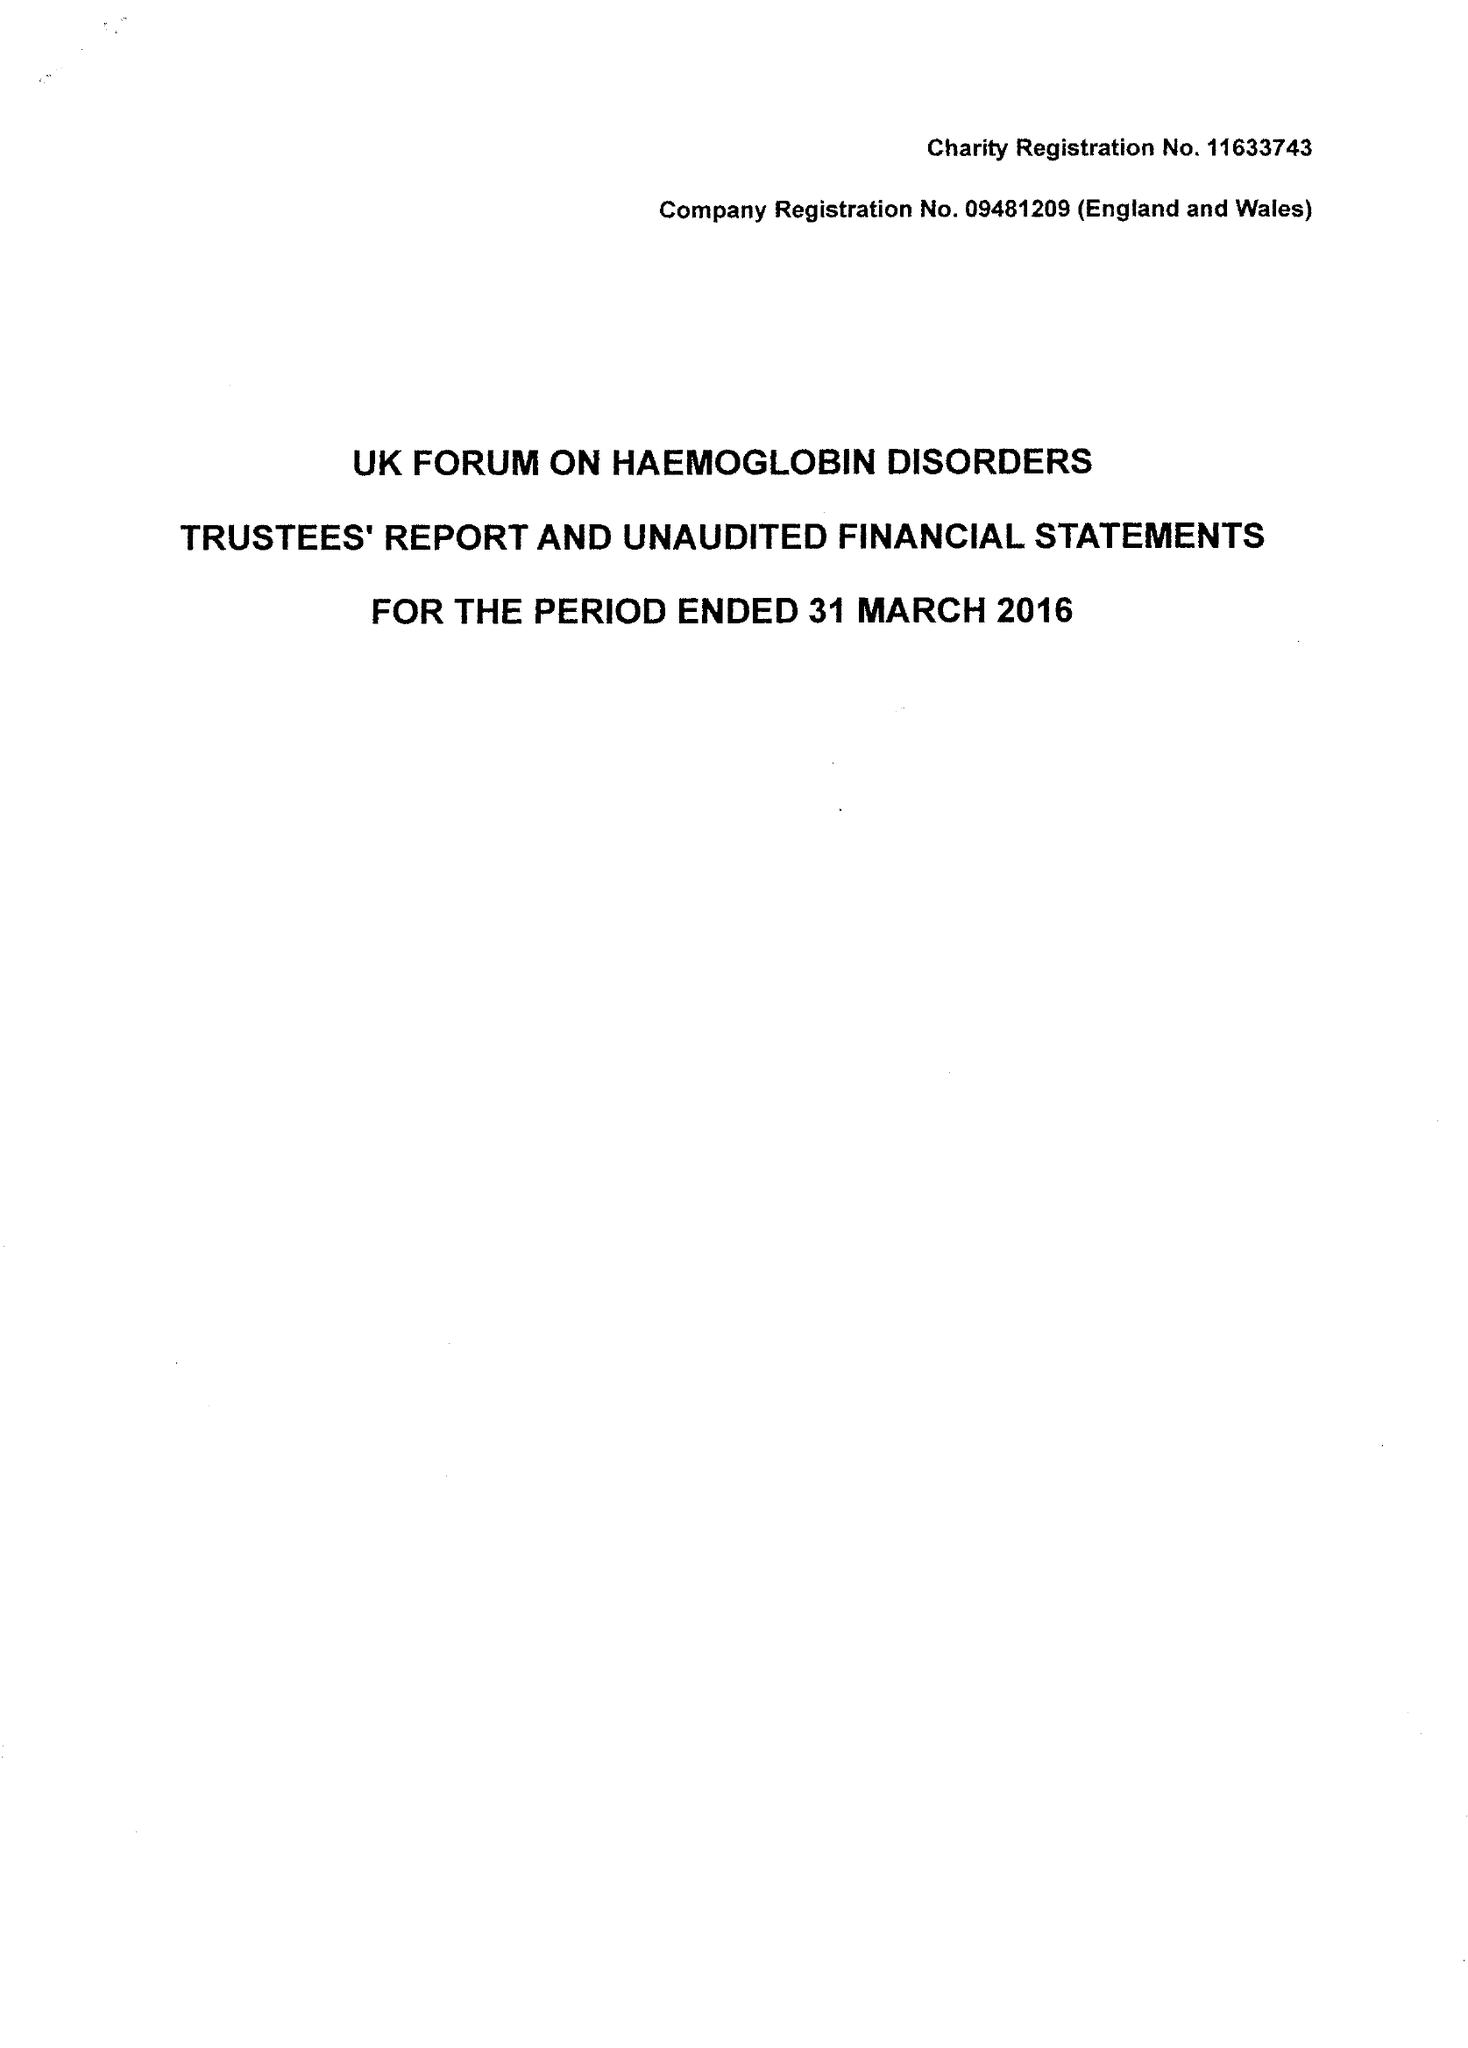What is the value for the address__post_town?
Answer the question using a single word or phrase. LONDON 